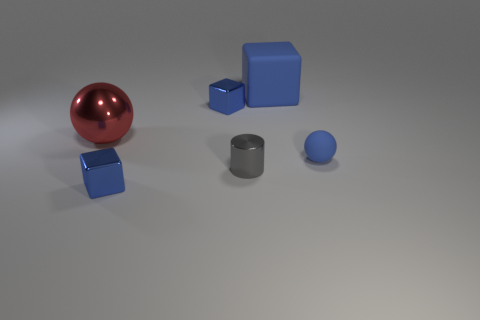What is the shape of the gray shiny thing that is the same size as the blue ball?
Offer a very short reply. Cylinder. Is the number of purple metallic blocks less than the number of tiny metal objects?
Offer a very short reply. Yes. There is a metallic cube behind the red metal sphere; is there a tiny blue metallic block that is on the left side of it?
Your response must be concise. Yes. Are there any shiny objects behind the rubber object in front of the blue metallic object behind the tiny cylinder?
Your answer should be very brief. Yes. There is a big object that is to the right of the metallic sphere; is it the same shape as the thing that is to the right of the large rubber cube?
Offer a terse response. No. There is a sphere that is made of the same material as the tiny cylinder; what color is it?
Your answer should be compact. Red. Is the number of shiny cylinders behind the small shiny cylinder less than the number of blue metallic blocks?
Your answer should be compact. Yes. There is a metal cube behind the shiny object in front of the tiny gray object in front of the large blue matte thing; what is its size?
Keep it short and to the point. Small. Does the small blue cube behind the small rubber object have the same material as the small blue sphere?
Make the answer very short. No. What material is the big block that is the same color as the tiny rubber ball?
Offer a very short reply. Rubber. 